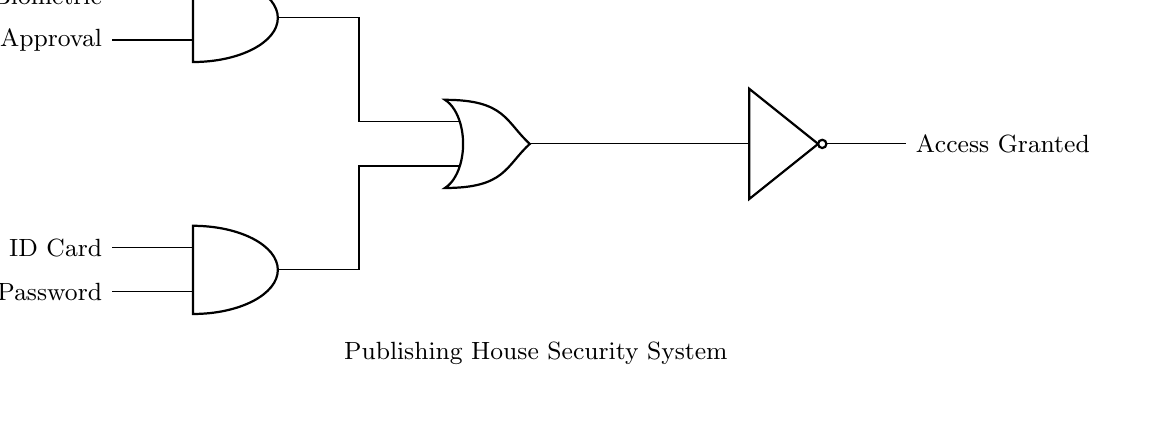What type of logic gates are used in this circuit? The diagram shows two AND gates, one OR gate, and one NOT gate. These types of gates perform specific logical operations, contributing to the access control function of the circuit.
Answer: AND, OR, NOT What are the inputs for the first AND gate? The first AND gate receives two inputs: the ID Card and the Password. These inputs are essential for validating user access based on identification.
Answer: ID Card, Password How many total inputs are there in the circuit? There are four inputs in total: two for the first AND gate (ID Card and Password) and two for the second AND gate (Biometric and Admin Approval). This reflects the multi-factor authentication aspect of the access control system.
Answer: Four What is the output of the OR gate when one input is active? The output of the OR gate will be high or active if either of its inputs (output from the first or second AND gate) is high. This functionality allows for more flexibility in access control scenarios.
Answer: Access Granted What conditions must be met for access to be denied? Access is denied when neither of the AND gates outputs a high signal, meaning that either both conditions for the ID Card and Password verification, or both for the Biometric and Admin Approval authentication, must fail. This ensures higher security.
Answer: Both AND gates low If both AND gates output high, what is the final output of the NOT gate? If both AND gates output high, the NOT gate will produce a low output because it inverts the signal it receives. The NOT gate plays a critical role in ensuring that a high signal (access request) is effectively managed.
Answer: Access Denied How many AND gates are in this access control system? There are two AND gates present in this access control system, each serving to verify different sets of authentication criteria for access approval.
Answer: Two 